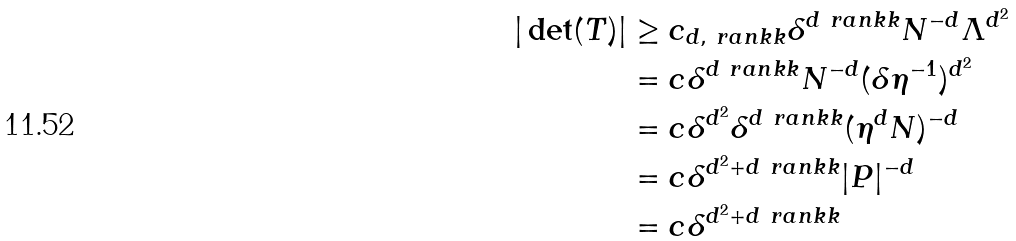<formula> <loc_0><loc_0><loc_500><loc_500>| \det ( T ) | & \geq c _ { d , \ r a n k k } \delta ^ { d \ r a n k k } N ^ { - d } \Lambda ^ { d ^ { 2 } } \\ & = c \delta ^ { d \ r a n k k } N ^ { - d } ( \delta \eta ^ { - 1 } ) ^ { d ^ { 2 } } \\ & = c \delta ^ { d ^ { 2 } } \delta ^ { d \ r a n k k } ( \eta ^ { d } N ) ^ { - d } \\ & = c \delta ^ { d ^ { 2 } + d \ r a n k k } | P | ^ { - d } \\ & = c \delta ^ { d ^ { 2 } + d \ r a n k k }</formula> 